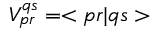Convert formula to latex. <formula><loc_0><loc_0><loc_500><loc_500>V _ { p r } ^ { q s } = < p r | q s ></formula> 